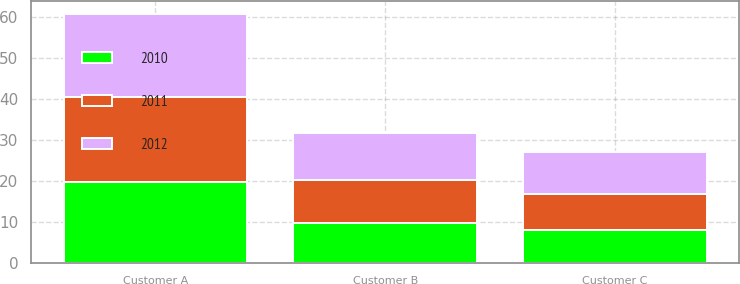<chart> <loc_0><loc_0><loc_500><loc_500><stacked_bar_chart><ecel><fcel>Customer A<fcel>Customer B<fcel>Customer C<nl><fcel>2012<fcel>20.4<fcel>11.4<fcel>10.3<nl><fcel>2011<fcel>20.7<fcel>10.5<fcel>8.9<nl><fcel>2010<fcel>19.8<fcel>9.8<fcel>8<nl></chart> 